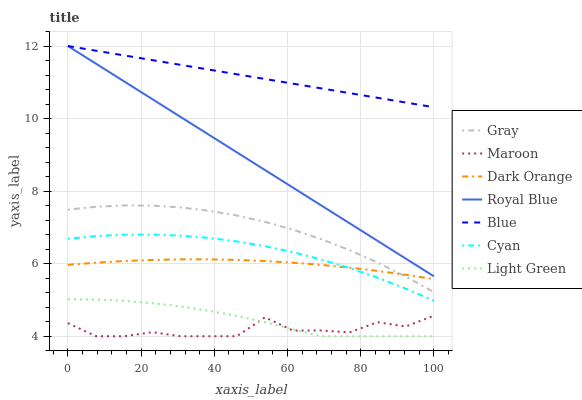Does Maroon have the minimum area under the curve?
Answer yes or no. Yes. Does Blue have the maximum area under the curve?
Answer yes or no. Yes. Does Gray have the minimum area under the curve?
Answer yes or no. No. Does Gray have the maximum area under the curve?
Answer yes or no. No. Is Royal Blue the smoothest?
Answer yes or no. Yes. Is Maroon the roughest?
Answer yes or no. Yes. Is Gray the smoothest?
Answer yes or no. No. Is Gray the roughest?
Answer yes or no. No. Does Maroon have the lowest value?
Answer yes or no. Yes. Does Gray have the lowest value?
Answer yes or no. No. Does Royal Blue have the highest value?
Answer yes or no. Yes. Does Gray have the highest value?
Answer yes or no. No. Is Light Green less than Blue?
Answer yes or no. Yes. Is Dark Orange greater than Light Green?
Answer yes or no. Yes. Does Light Green intersect Maroon?
Answer yes or no. Yes. Is Light Green less than Maroon?
Answer yes or no. No. Is Light Green greater than Maroon?
Answer yes or no. No. Does Light Green intersect Blue?
Answer yes or no. No. 